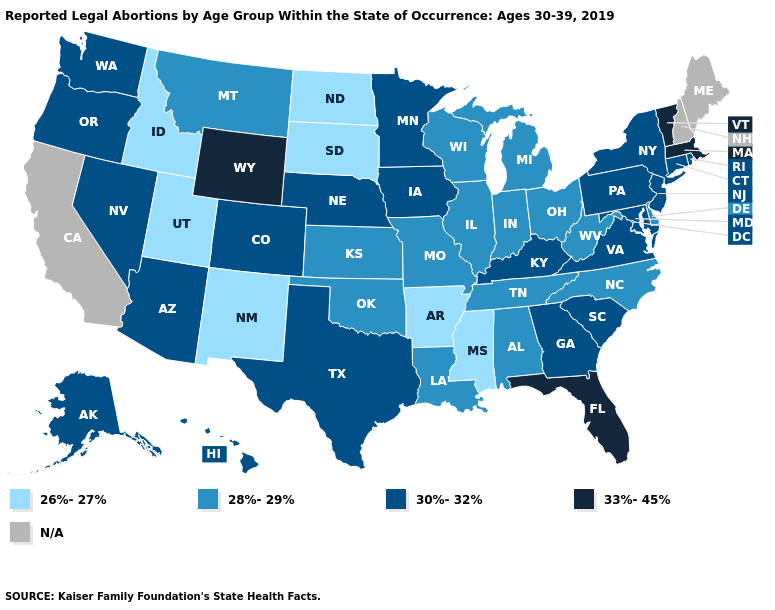Name the states that have a value in the range N/A?
Concise answer only. California, Maine, New Hampshire. Does Delaware have the highest value in the USA?
Short answer required. No. What is the value of Kansas?
Give a very brief answer. 28%-29%. What is the lowest value in the West?
Short answer required. 26%-27%. Name the states that have a value in the range 28%-29%?
Answer briefly. Alabama, Delaware, Illinois, Indiana, Kansas, Louisiana, Michigan, Missouri, Montana, North Carolina, Ohio, Oklahoma, Tennessee, West Virginia, Wisconsin. Among the states that border Washington , does Oregon have the highest value?
Short answer required. Yes. What is the value of Washington?
Answer briefly. 30%-32%. What is the value of Indiana?
Concise answer only. 28%-29%. What is the highest value in states that border Montana?
Answer briefly. 33%-45%. Name the states that have a value in the range 33%-45%?
Answer briefly. Florida, Massachusetts, Vermont, Wyoming. What is the value of Virginia?
Keep it brief. 30%-32%. What is the highest value in the USA?
Keep it brief. 33%-45%. Does the map have missing data?
Concise answer only. Yes. 